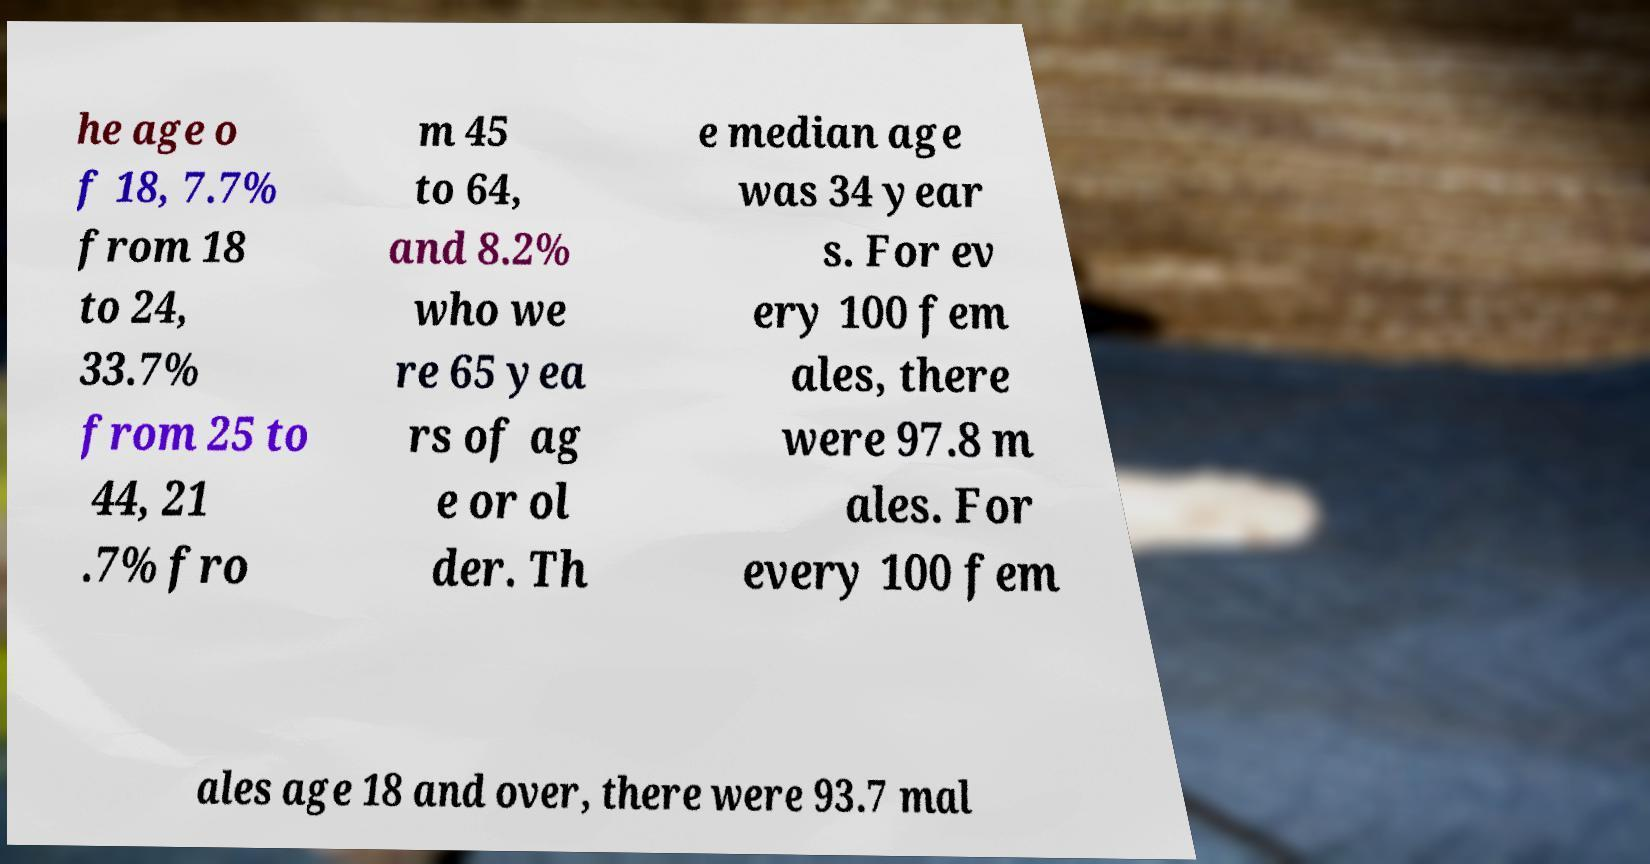Please identify and transcribe the text found in this image. he age o f 18, 7.7% from 18 to 24, 33.7% from 25 to 44, 21 .7% fro m 45 to 64, and 8.2% who we re 65 yea rs of ag e or ol der. Th e median age was 34 year s. For ev ery 100 fem ales, there were 97.8 m ales. For every 100 fem ales age 18 and over, there were 93.7 mal 